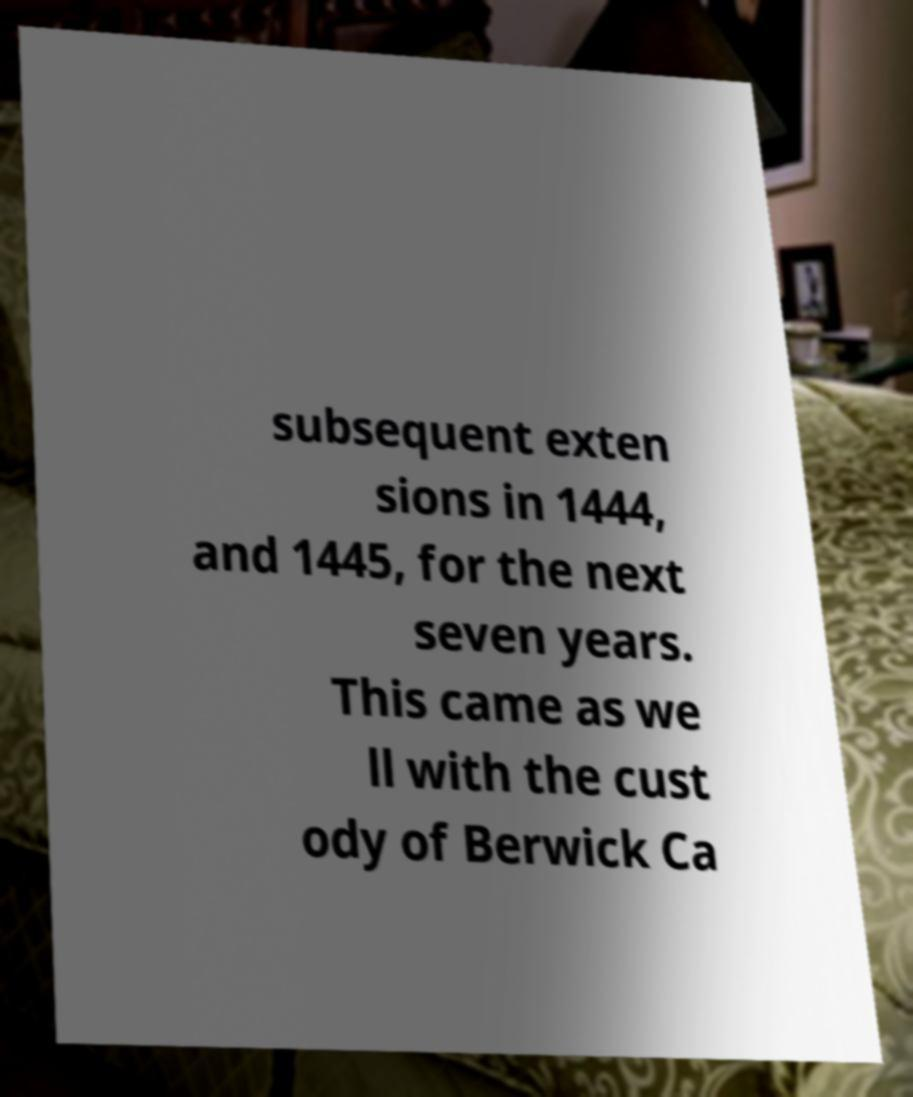Please identify and transcribe the text found in this image. subsequent exten sions in 1444, and 1445, for the next seven years. This came as we ll with the cust ody of Berwick Ca 